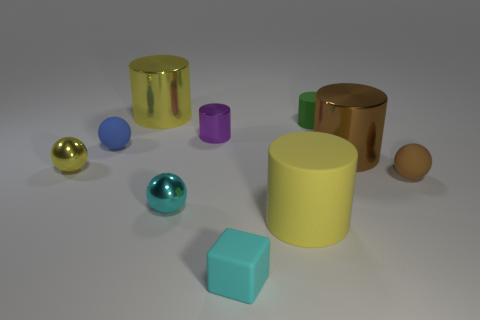What size is the metallic object that is the same color as the small block?
Give a very brief answer. Small. Does the small cyan shiny thing have the same shape as the small brown thing?
Make the answer very short. Yes. What is the color of the big matte thing?
Your response must be concise. Yellow. How many things are small brown things or small blue matte things?
Provide a succinct answer. 2. Is the number of tiny rubber blocks in front of the blue object less than the number of small things?
Your response must be concise. Yes. Are there more metallic things on the left side of the brown cylinder than spheres that are right of the small yellow sphere?
Keep it short and to the point. Yes. Is there any other thing of the same color as the small cube?
Your answer should be compact. Yes. What is the big brown object that is right of the big yellow metal thing made of?
Your answer should be very brief. Metal. Is the yellow metallic cylinder the same size as the green cylinder?
Offer a terse response. No. What number of other things are there of the same size as the yellow rubber cylinder?
Offer a terse response. 2. 